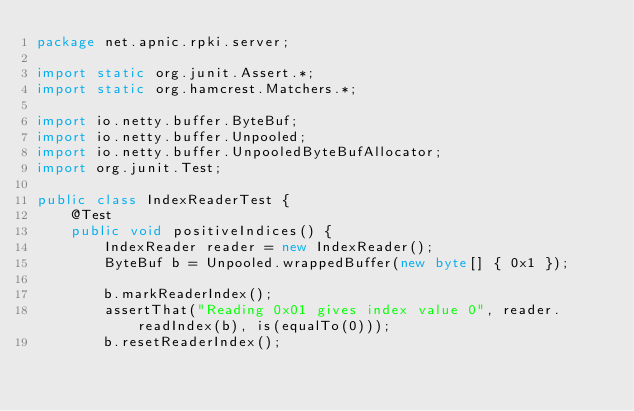Convert code to text. <code><loc_0><loc_0><loc_500><loc_500><_Java_>package net.apnic.rpki.server;

import static org.junit.Assert.*;
import static org.hamcrest.Matchers.*;

import io.netty.buffer.ByteBuf;
import io.netty.buffer.Unpooled;
import io.netty.buffer.UnpooledByteBufAllocator;
import org.junit.Test;

public class IndexReaderTest {
    @Test
    public void positiveIndices() {
        IndexReader reader = new IndexReader();
        ByteBuf b = Unpooled.wrappedBuffer(new byte[] { 0x1 });

        b.markReaderIndex();
        assertThat("Reading 0x01 gives index value 0", reader.readIndex(b), is(equalTo(0)));
        b.resetReaderIndex();</code> 